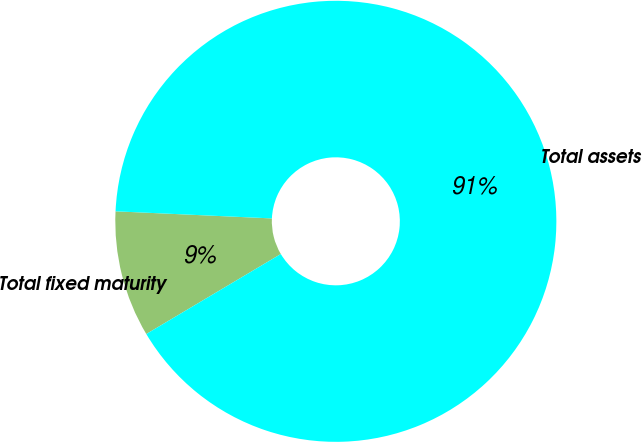<chart> <loc_0><loc_0><loc_500><loc_500><pie_chart><fcel>Total fixed maturity<fcel>Total assets<nl><fcel>9.26%<fcel>90.74%<nl></chart> 